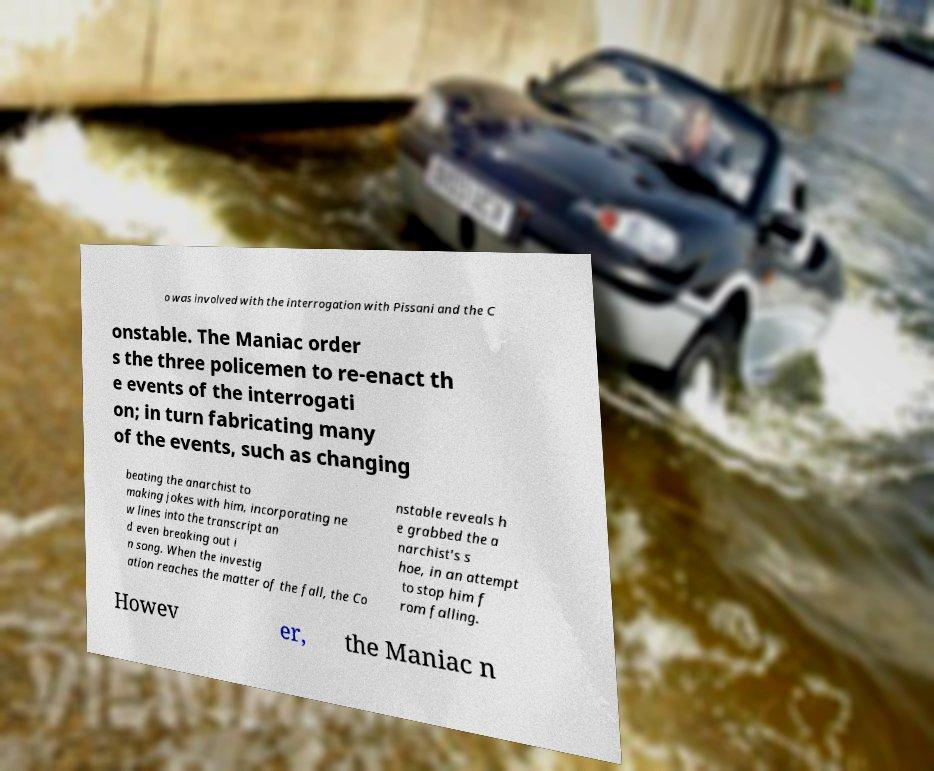Please identify and transcribe the text found in this image. o was involved with the interrogation with Pissani and the C onstable. The Maniac order s the three policemen to re-enact th e events of the interrogati on; in turn fabricating many of the events, such as changing beating the anarchist to making jokes with him, incorporating ne w lines into the transcript an d even breaking out i n song. When the investig ation reaches the matter of the fall, the Co nstable reveals h e grabbed the a narchist's s hoe, in an attempt to stop him f rom falling. Howev er, the Maniac n 